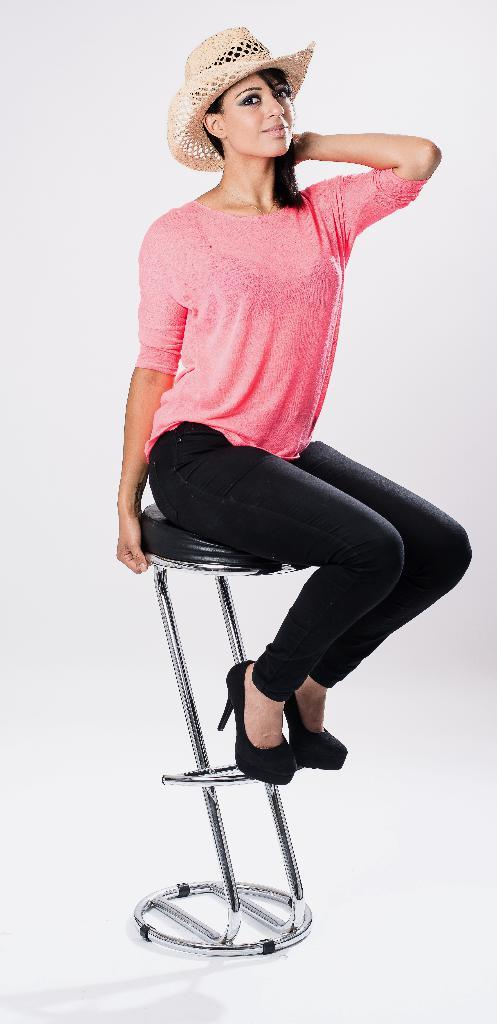Who is the main subject in the image? There is a lady in the image. What is the lady doing in the image? The lady is sitting on a chair. What color is the lady's top? The lady is wearing a pink top. What type of pants is the lady wearing? The lady is wearing black jeans. What accessory is the lady wearing on her head? The lady is wearing a hat. What is the lady's opinion on the existence of extraterrestrial life? There is no information about the lady's opinion on the existence of extraterrestrial life in the image. 